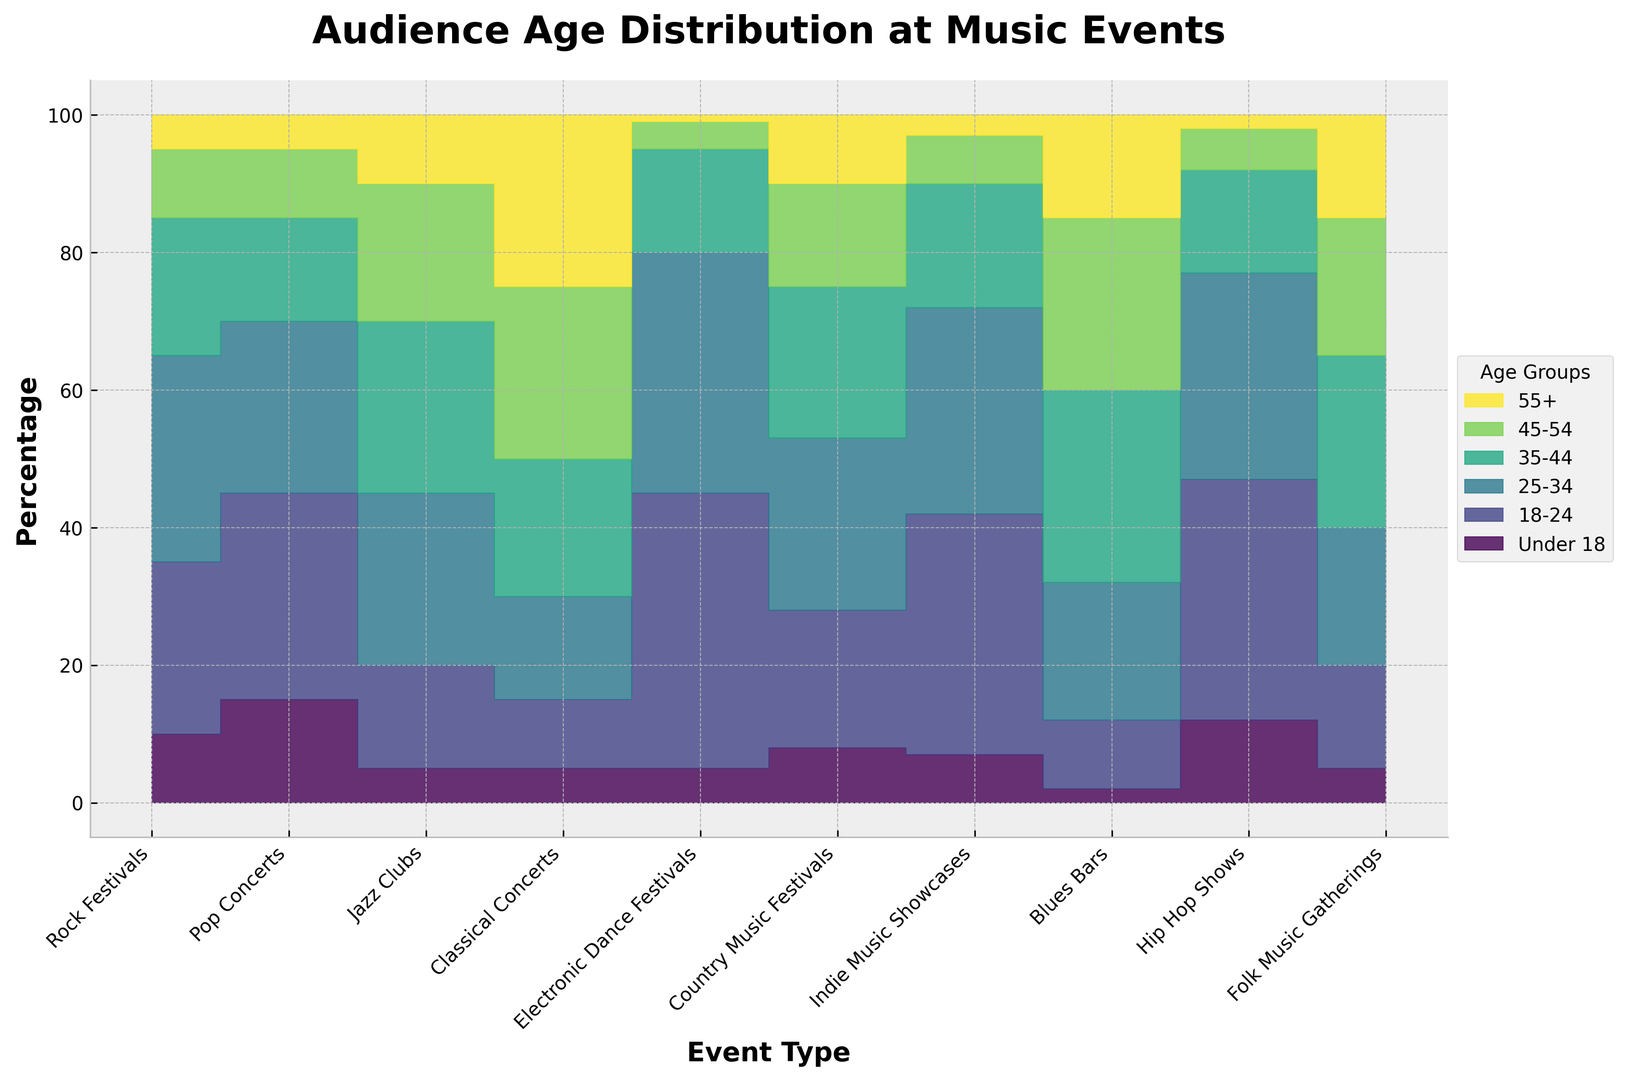Which event type has the highest percentage of audience aged 18-24? Look at the height of the area for the 18-24 age group across all events. The highest is seen in Electronic Dance Festivals.
Answer: Electronic Dance Festivals Which two event types have the smallest audience percentage under 18? Identify the smallest area at the bottom of the chart for the Under 18 group. These are Blues Bars with 2% and Jazz Clubs with 5%.
Answer: Blues Bars and Jazz Clubs Compare the audience aged 35-44 at Rock Festivals and Jazz Clubs. Which has a higher percentage, and by how much? The area for 35-44 age group in Rock Festivals is 20% and in Jazz Clubs is 25%. Subtract 20% from 25% to find the difference.
Answer: Jazz Clubs by 5% What is the total percentage of the audience aged 18-34 at Pop Concerts? The 18-24 group is 30% and the 25-34 group is 25% at Pop Concerts. Add these percentages: 30 + 25 = 55%.
Answer: 55% Which event type has the most balanced age distribution? A balanced distribution would have roughly equal areas for each age group. Classical Concerts and Country Music Festivals appear to have the most even distribution.
Answer: Classical Concerts and Country Music Festivals How does the percentage of audience aged 55+ at Classical Concerts compare to that at Electronic Dance Festivals? The age 55+ group is represented by the top area. Classical Concerts have 25%, and Electronic Dance Festivals have 1%. Subtract the smaller from the larger: 25 - 1 = 24%.
Answer: Classical Concerts by 24% For Hip Hop Shows, what is the combined percentage of audiences aged 18-24 and 25-34? Sum the percentages of the 18-24 group (35%) and the 25-34 group (30%): 35 + 30 = 65%.
Answer: 65% What is the difference in audience percentage aged 45-54 between Blues Bars and Indie Music Showcases? The percentage for 45-54 is 25% in Blues Bars and 7% in Indie Music Showcases. Subtract the smaller from the larger: 25 - 7 = 18%.
Answer: 18% Which event type has the highest percentage of audiences aged 25-34, and what is that percentage? Identify the highest area segment for the 25-34 age group. Electronic Dance Festivals have the highest at 35%.
Answer: Electronic Dance Festivals, 35% What percentage of the total audience at Folk Music Gatherings is aged 35 or older? Sum the percentages for the 35-44 (25%), 45-54 (20%), and 55+ (15%) groups: 25 + 20 + 15 = 60%.
Answer: 60% 